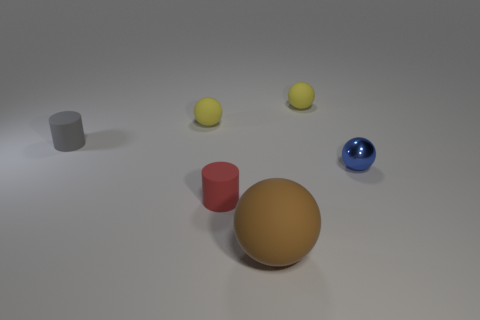There is a small cylinder that is to the left of the cylinder in front of the tiny gray rubber thing; what is its material? The small cylinder to the left of the other cylinder and in front of the tiny gray object appears to be made of matte plastic material, distinguishable by its solid color and lack of reflections typical of rubber. 